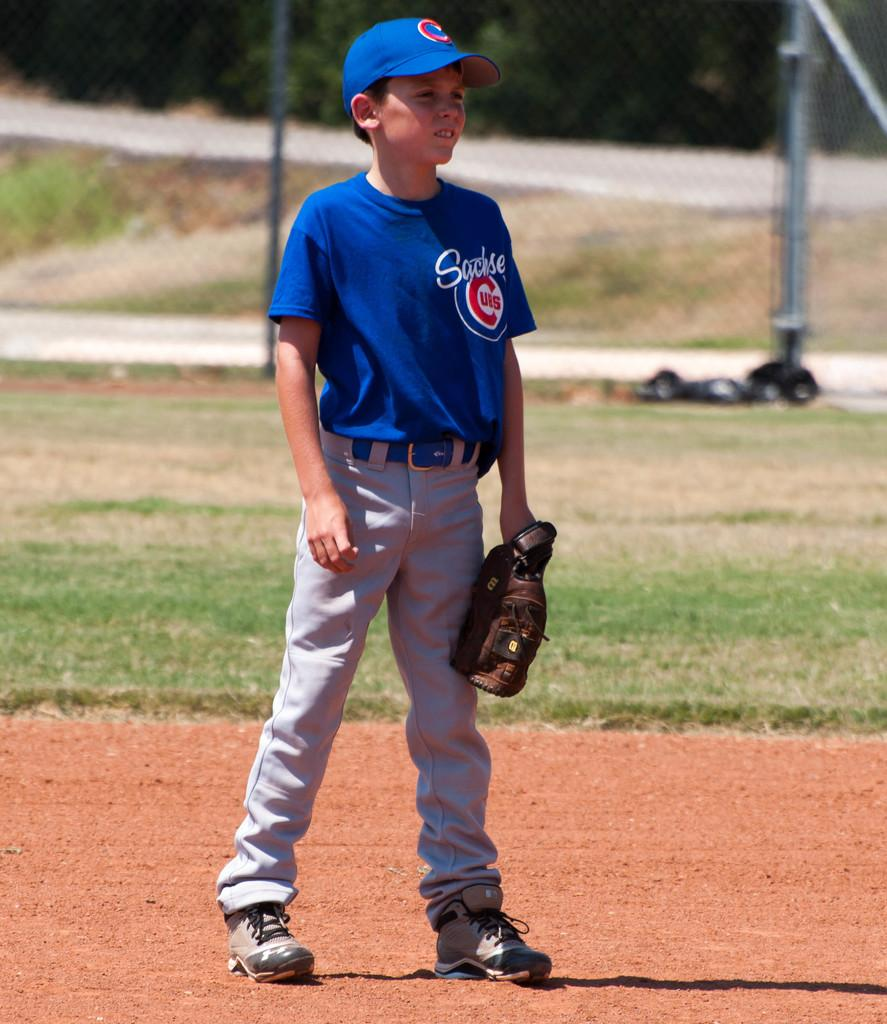Who is the main subject in the image? There is a boy in the image. What is the boy holding in the image? The boy is holding an object. Can you describe the object's location in the image? The object is visible on the ground. What is visible in the background of the image? There is a fence behind the boy. What type of brush can be seen in the boy's hand in the image? There is no brush visible in the boy's hand in the image. 